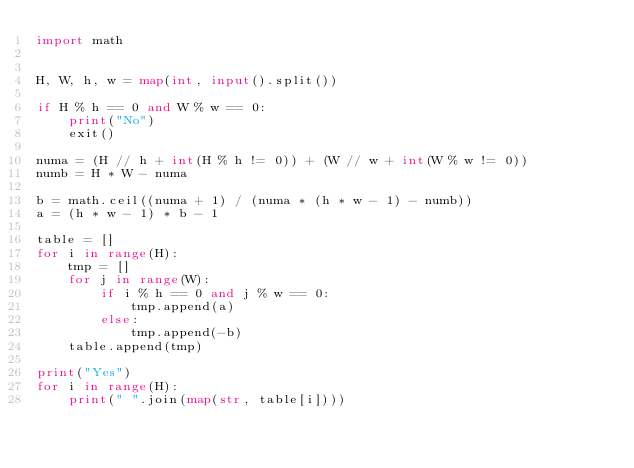Convert code to text. <code><loc_0><loc_0><loc_500><loc_500><_Python_>import math


H, W, h, w = map(int, input().split())

if H % h == 0 and W % w == 0:
    print("No")
    exit()

numa = (H // h + int(H % h != 0)) + (W // w + int(W % w != 0))
numb = H * W - numa

b = math.ceil((numa + 1) / (numa * (h * w - 1) - numb))
a = (h * w - 1) * b - 1

table = []
for i in range(H):
    tmp = []
    for j in range(W):
        if i % h == 0 and j % w == 0:
            tmp.append(a)
        else:
            tmp.append(-b)
    table.append(tmp)

print("Yes")
for i in range(H):
    print(" ".join(map(str, table[i])))
</code> 